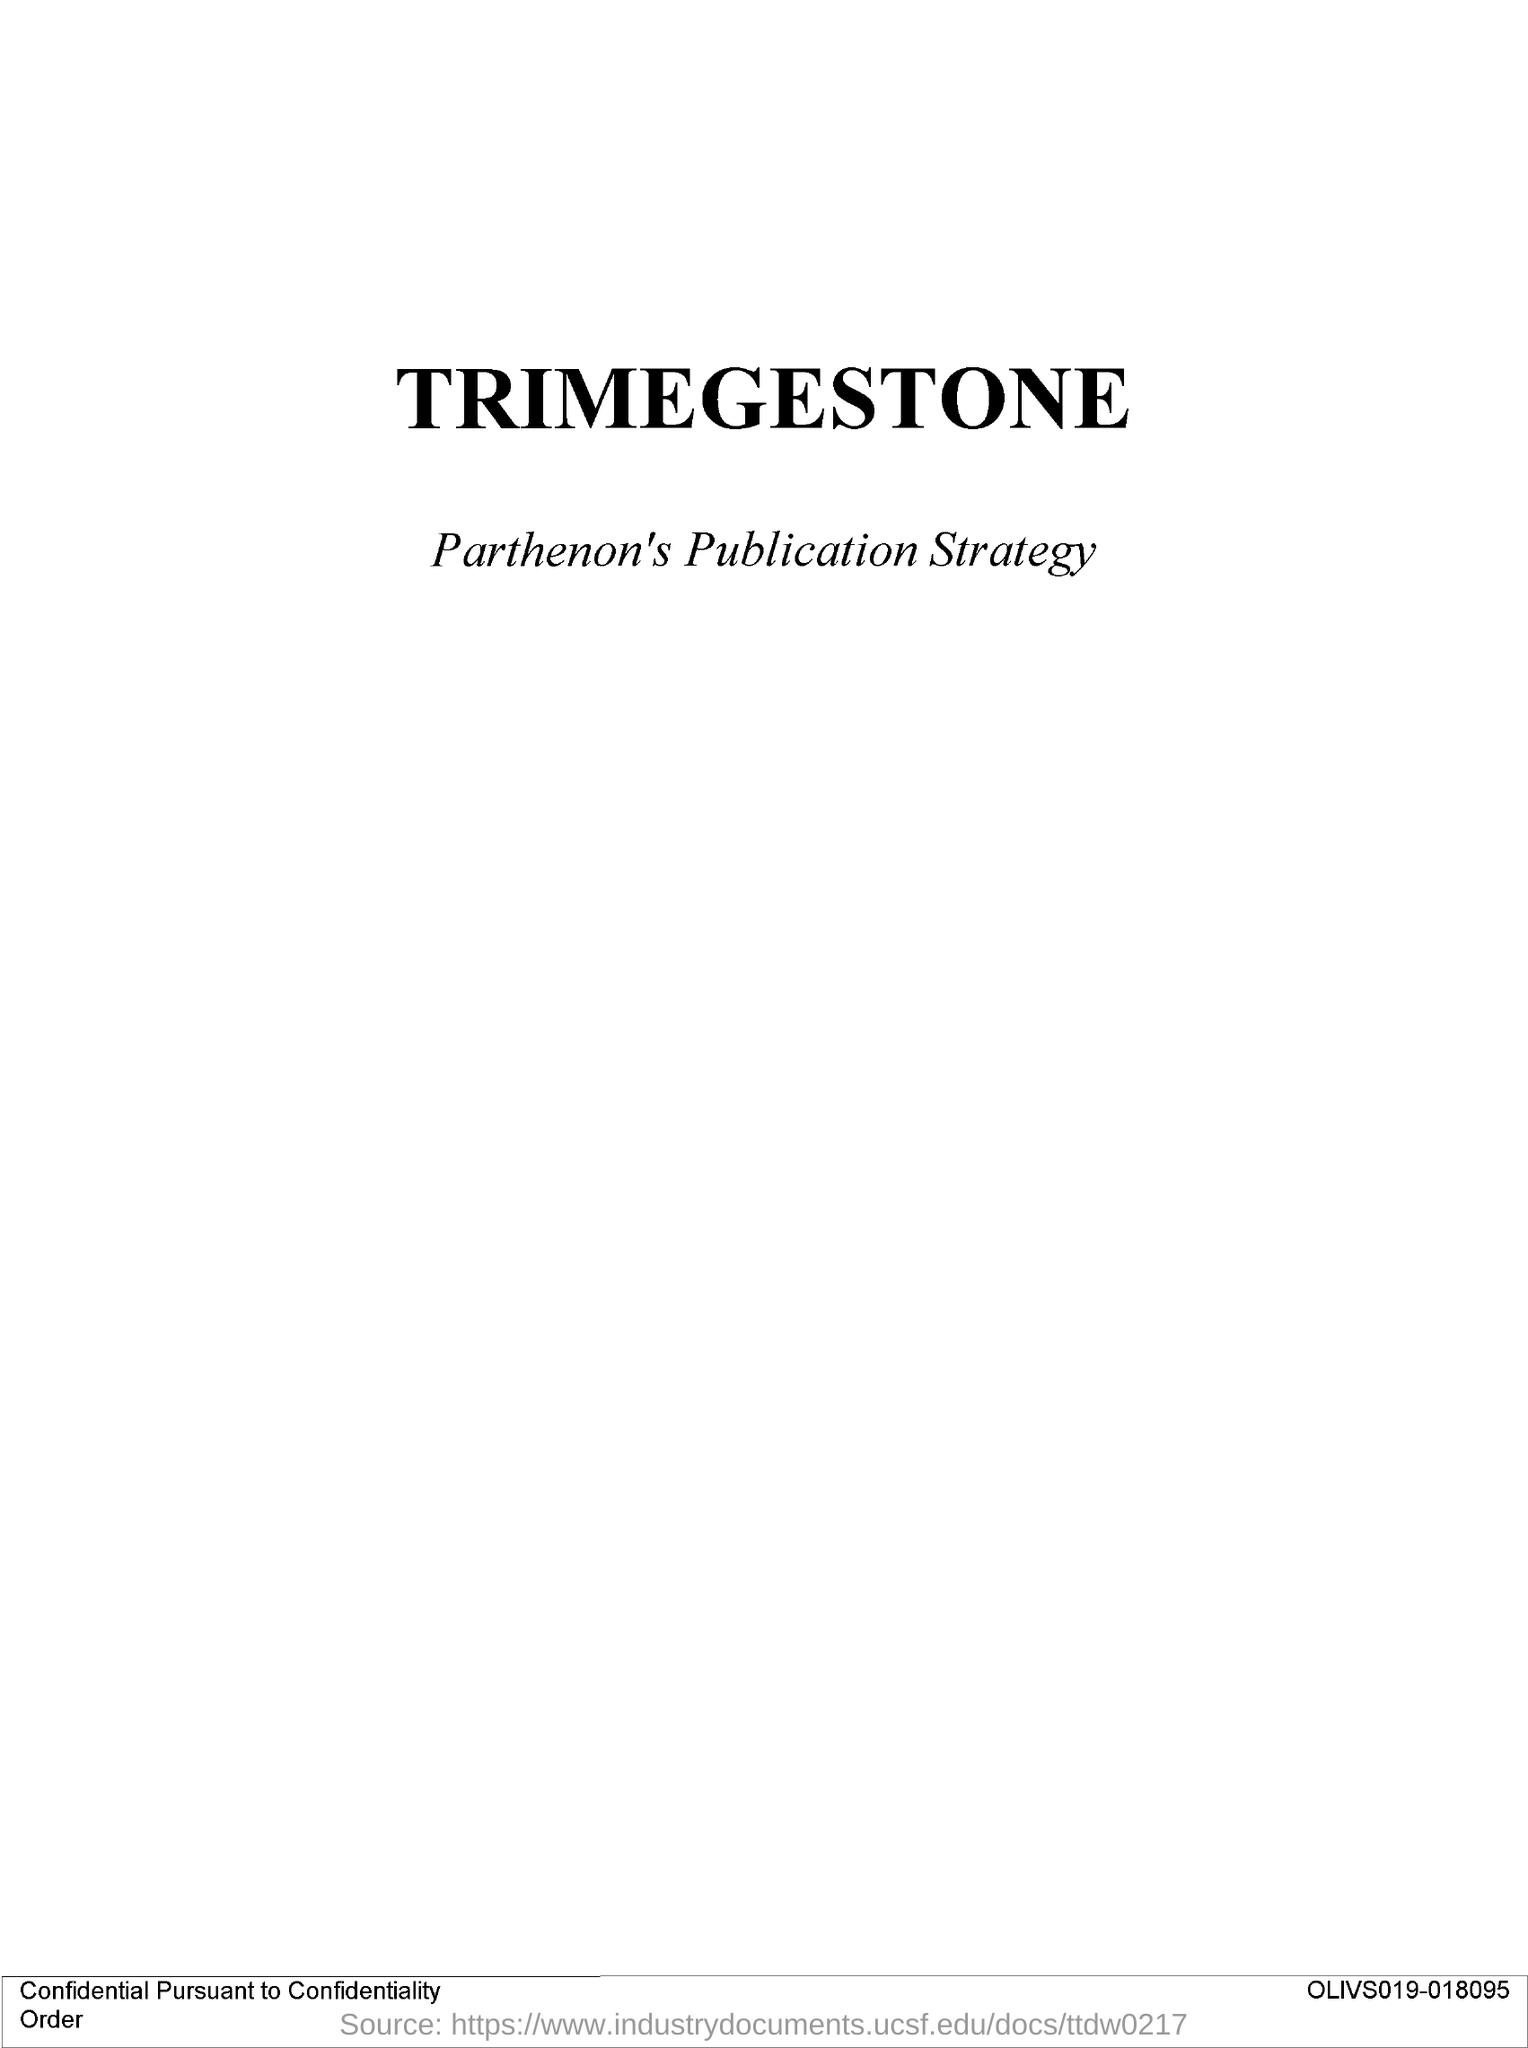List a handful of essential elements in this visual. The alphanumerical sequence located at the bottom right of the document is OLIVS019-018095... The title of the document is 'Trimegestone'. 